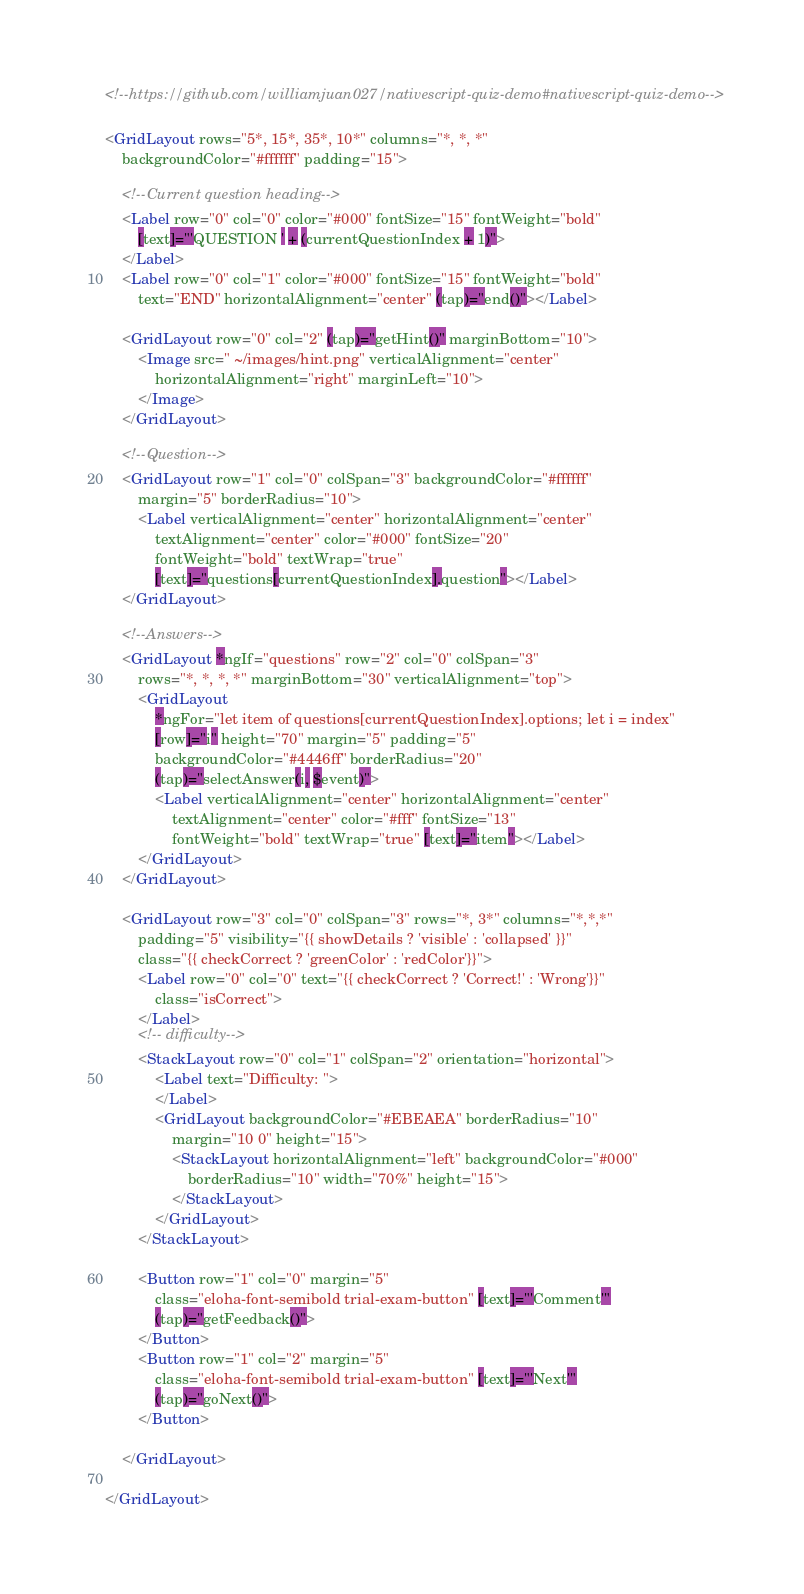Convert code to text. <code><loc_0><loc_0><loc_500><loc_500><_HTML_><!--https://github.com/williamjuan027/nativescript-quiz-demo#nativescript-quiz-demo-->

<GridLayout rows="5*, 15*, 35*, 10*" columns="*, *, *"
    backgroundColor="#ffffff" padding="15">

    <!--Current question heading-->
    <Label row="0" col="0" color="#000" fontSize="15" fontWeight="bold"
        [text]="'QUESTION ' + (currentQuestionIndex + 1)">
    </Label>
    <Label row="0" col="1" color="#000" fontSize="15" fontWeight="bold"
        text="END" horizontalAlignment="center" (tap)="end()"></Label>

    <GridLayout row="0" col="2" (tap)="getHint()" marginBottom="10">
        <Image src=" ~/images/hint.png" verticalAlignment="center"
            horizontalAlignment="right" marginLeft="10">
        </Image>
    </GridLayout>

    <!--Question-->
    <GridLayout row="1" col="0" colSpan="3" backgroundColor="#ffffff"
        margin="5" borderRadius="10">
        <Label verticalAlignment="center" horizontalAlignment="center"
            textAlignment="center" color="#000" fontSize="20"
            fontWeight="bold" textWrap="true"
            [text]="questions[currentQuestionIndex].question"></Label>
    </GridLayout>

    <!--Answers-->
    <GridLayout *ngIf="questions" row="2" col="0" colSpan="3"
        rows="*, *, *, *" marginBottom="30" verticalAlignment="top">
        <GridLayout
            *ngFor="let item of questions[currentQuestionIndex].options; let i = index"
            [row]="i" height="70" margin="5" padding="5"
            backgroundColor="#4446ff" borderRadius="20"
            (tap)="selectAnswer(i, $event)">
            <Label verticalAlignment="center" horizontalAlignment="center"
                textAlignment="center" color="#fff" fontSize="13"
                fontWeight="bold" textWrap="true" [text]="item"></Label>
        </GridLayout>
    </GridLayout>

    <GridLayout row="3" col="0" colSpan="3" rows="*, 3*" columns="*,*,*"
        padding="5" visibility="{{ showDetails ? 'visible' : 'collapsed' }}"
        class="{{ checkCorrect ? 'greenColor' : 'redColor'}}">
        <Label row="0" col="0" text="{{ checkCorrect ? 'Correct!' : 'Wrong'}}"
            class="isCorrect">
        </Label>
        <!-- difficulty-->
        <StackLayout row="0" col="1" colSpan="2" orientation="horizontal">
            <Label text="Difficulty: ">
            </Label>
            <GridLayout backgroundColor="#EBEAEA" borderRadius="10"
                margin="10 0" height="15">
                <StackLayout horizontalAlignment="left" backgroundColor="#000"
                    borderRadius="10" width="70%" height="15">
                </StackLayout>
            </GridLayout>
        </StackLayout>

        <Button row="1" col="0" margin="5"
            class="eloha-font-semibold trial-exam-button" [text]="'Comment'"
            (tap)="getFeedback()">
        </Button>
        <Button row="1" col="2" margin="5"
            class="eloha-font-semibold trial-exam-button" [text]="'Next'"
            (tap)="goNext()">
        </Button>

    </GridLayout>

</GridLayout></code> 